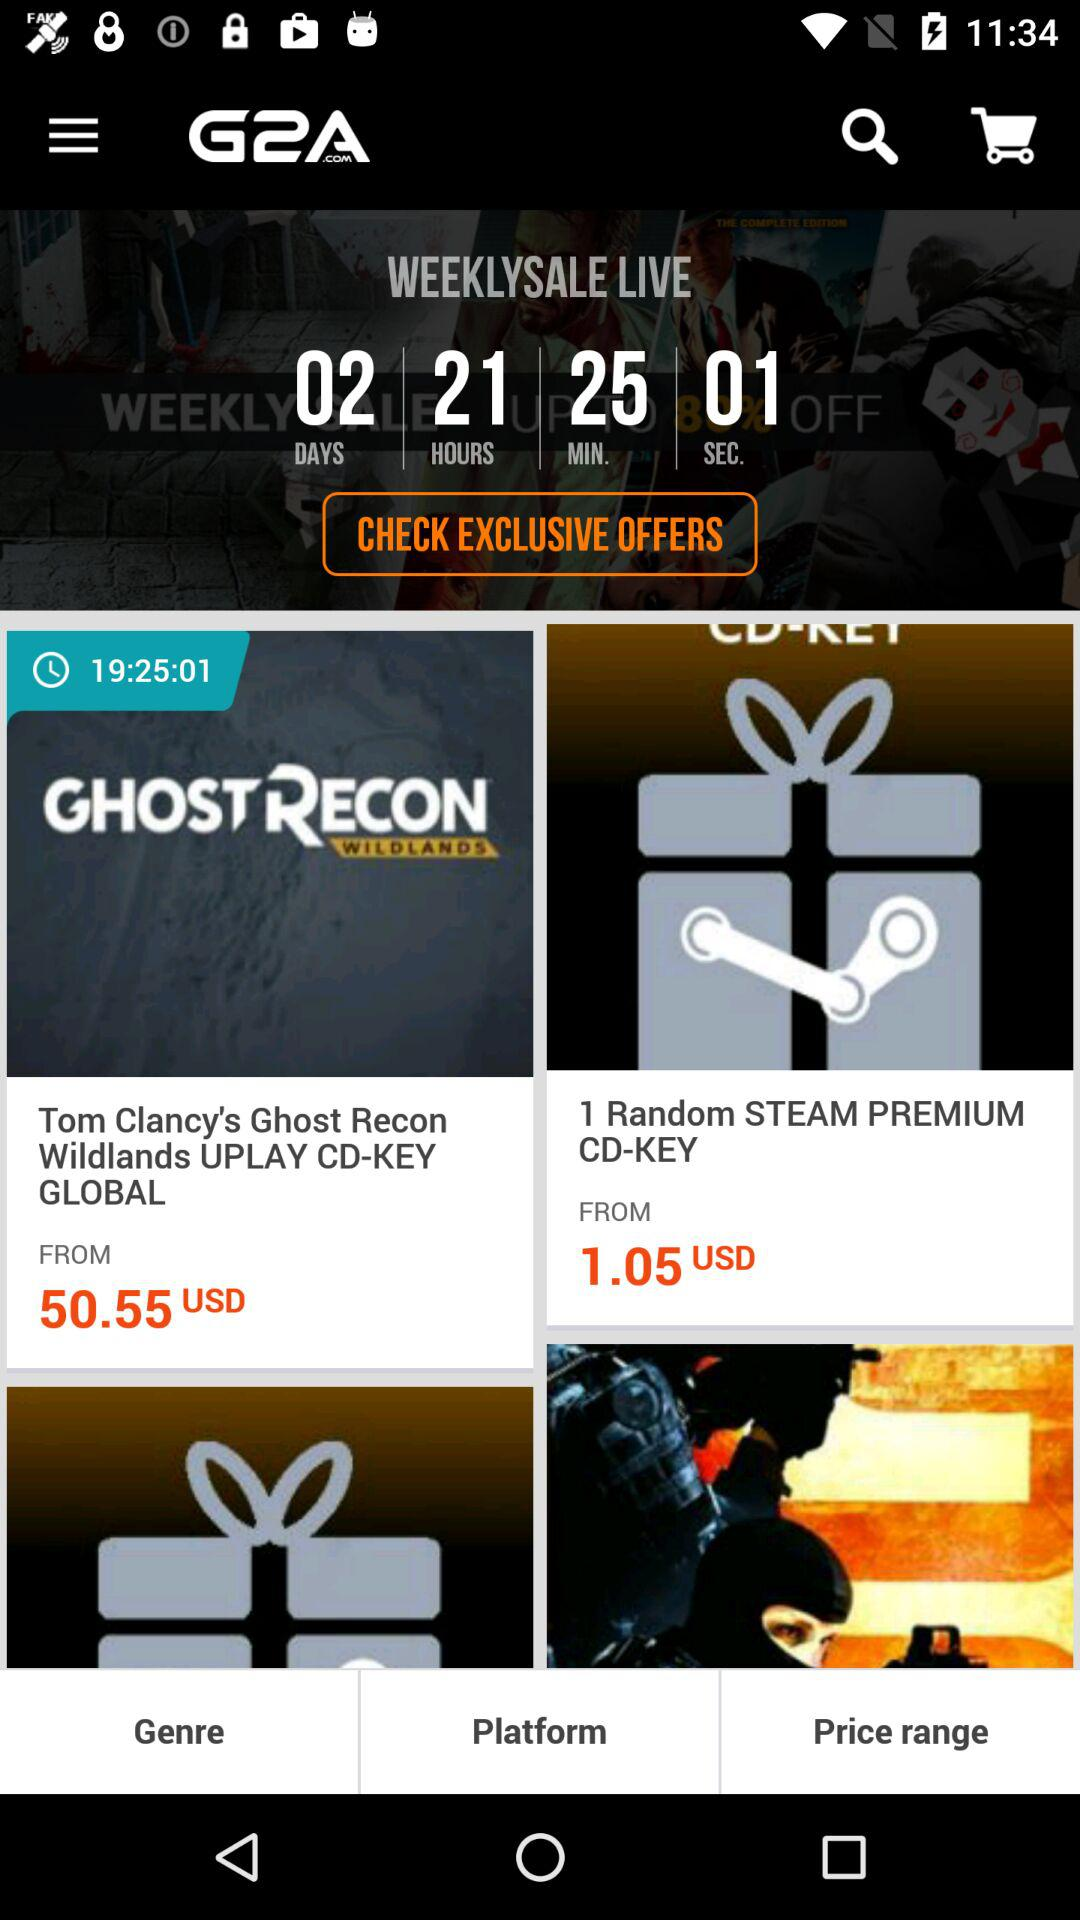What is the cost of one "Random STEAM PREMIUM CD-KEY"? The cost of one random steam premium CD-KEY is 1.05 USD. 